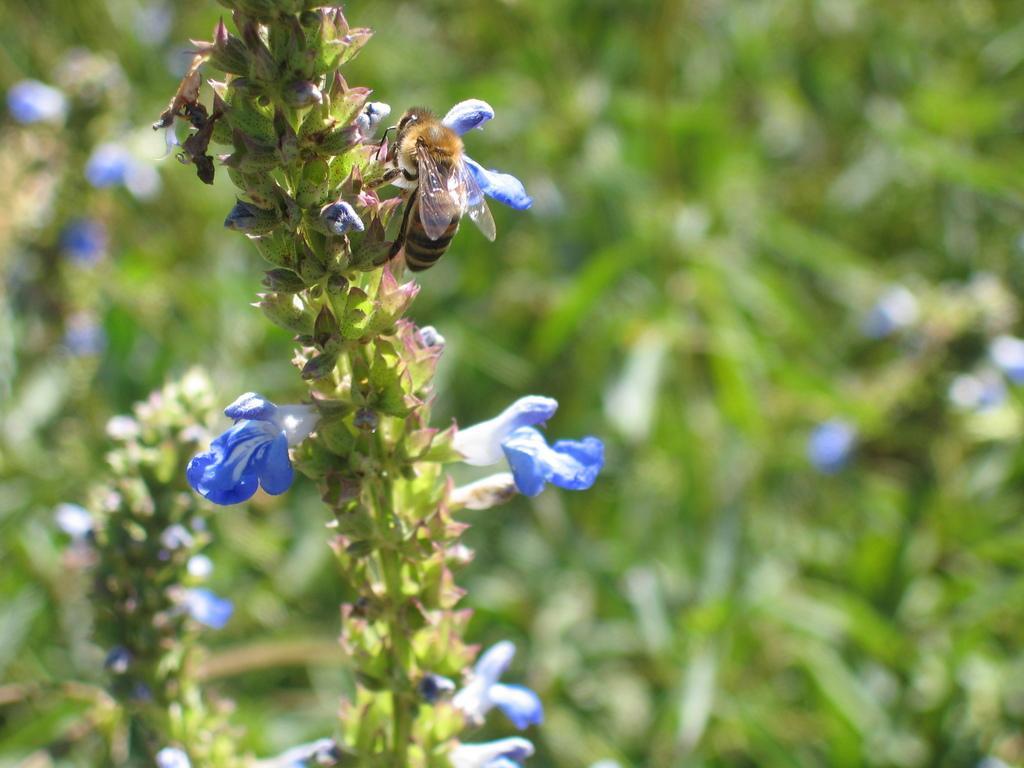Describe this image in one or two sentences. In this image there is a bee on a plant. 